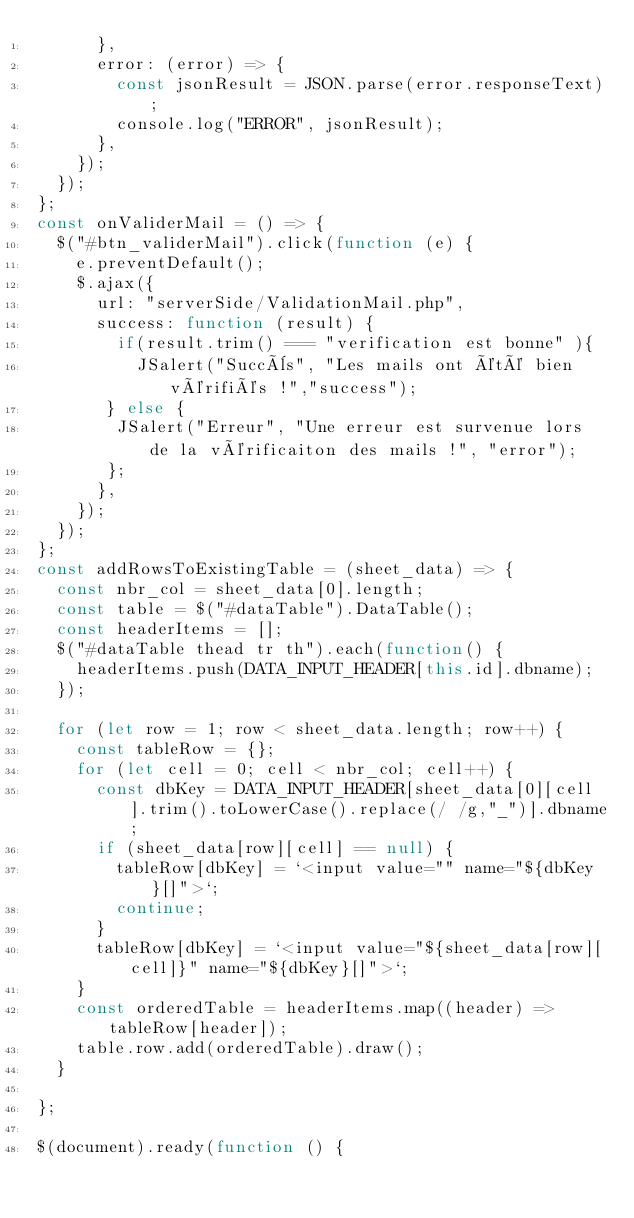Convert code to text. <code><loc_0><loc_0><loc_500><loc_500><_JavaScript_>      },
      error: (error) => {
        const jsonResult = JSON.parse(error.responseText);
        console.log("ERROR", jsonResult);
      },
    });
  });
};
const onValiderMail = () => {
  $("#btn_validerMail").click(function (e) {
    e.preventDefault();
    $.ajax({
      url: "serverSide/ValidationMail.php",
      success: function (result) {
        if(result.trim() === "verification est bonne" ){ 
          JSalert("Succès", "Les mails ont été bien vérifiés !","success");
       } else {
        JSalert("Erreur", "Une erreur est survenue lors de la vérificaiton des mails !", "error");
       };
      },
    });
  });
};
const addRowsToExistingTable = (sheet_data) => {
  const nbr_col = sheet_data[0].length;
  const table = $("#dataTable").DataTable();
  const headerItems = [];
  $("#dataTable thead tr th").each(function() {
    headerItems.push(DATA_INPUT_HEADER[this.id].dbname);
  });

  for (let row = 1; row < sheet_data.length; row++) {
    const tableRow = {};
    for (let cell = 0; cell < nbr_col; cell++) {
      const dbKey = DATA_INPUT_HEADER[sheet_data[0][cell].trim().toLowerCase().replace(/ /g,"_")].dbname;
      if (sheet_data[row][cell] == null) {
        tableRow[dbKey] = `<input value="" name="${dbKey}[]">`; 
        continue;
      }
      tableRow[dbKey] = `<input value="${sheet_data[row][cell]}" name="${dbKey}[]">`;
    }
    const orderedTable = headerItems.map((header) => tableRow[header]);
    table.row.add(orderedTable).draw();
  }
  
};

$(document).ready(function () {</code> 